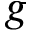<formula> <loc_0><loc_0><loc_500><loc_500>g</formula> 